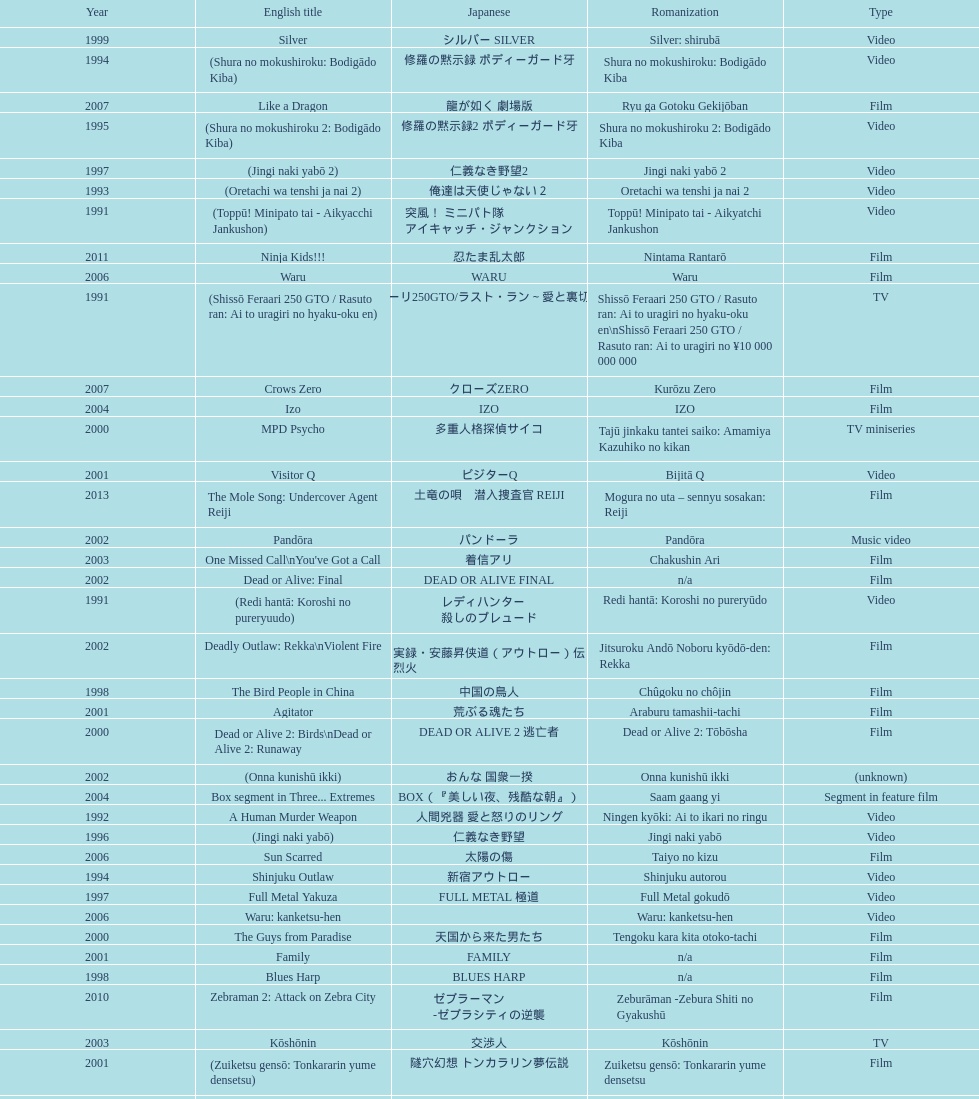How many years is the chart for? 23. 